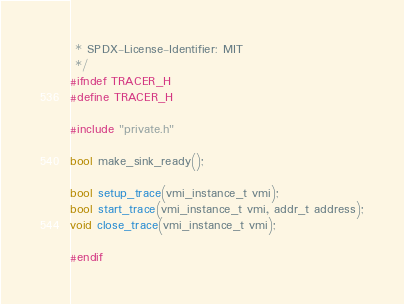<code> <loc_0><loc_0><loc_500><loc_500><_C_> * SPDX-License-Identifier: MIT
 */
#ifndef TRACER_H
#define TRACER_H

#include "private.h"

bool make_sink_ready();

bool setup_trace(vmi_instance_t vmi);
bool start_trace(vmi_instance_t vmi, addr_t address);
void close_trace(vmi_instance_t vmi);

#endif
</code> 